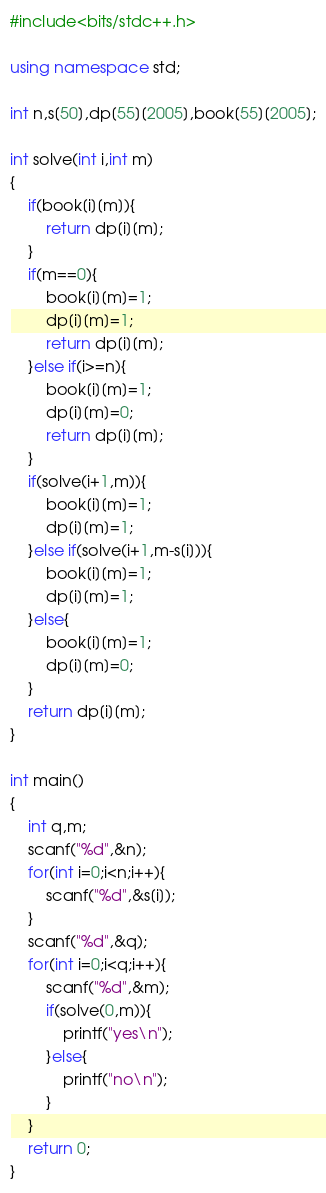<code> <loc_0><loc_0><loc_500><loc_500><_C++_>#include<bits/stdc++.h>
 
using namespace std;
 
int n,s[50],dp[55][2005],book[55][2005];
 
int solve(int i,int m)
{
    if(book[i][m]){
        return dp[i][m];
    }
    if(m==0){
        book[i][m]=1;
        dp[i][m]=1;
        return dp[i][m];
    }else if(i>=n){
        book[i][m]=1;
        dp[i][m]=0;
        return dp[i][m];
    }
    if(solve(i+1,m)){
        book[i][m]=1;
        dp[i][m]=1;
    }else if(solve(i+1,m-s[i])){
        book[i][m]=1;
        dp[i][m]=1;
    }else{
        book[i][m]=1;
        dp[i][m]=0;
    }
    return dp[i][m];
}
 
int main()
{
    int q,m;
    scanf("%d",&n);
    for(int i=0;i<n;i++){
        scanf("%d",&s[i]);
    }
    scanf("%d",&q);
    for(int i=0;i<q;i++){
        scanf("%d",&m);
        if(solve(0,m)){
            printf("yes\n");
        }else{
            printf("no\n");
        }
    }
    return 0;
}

</code> 